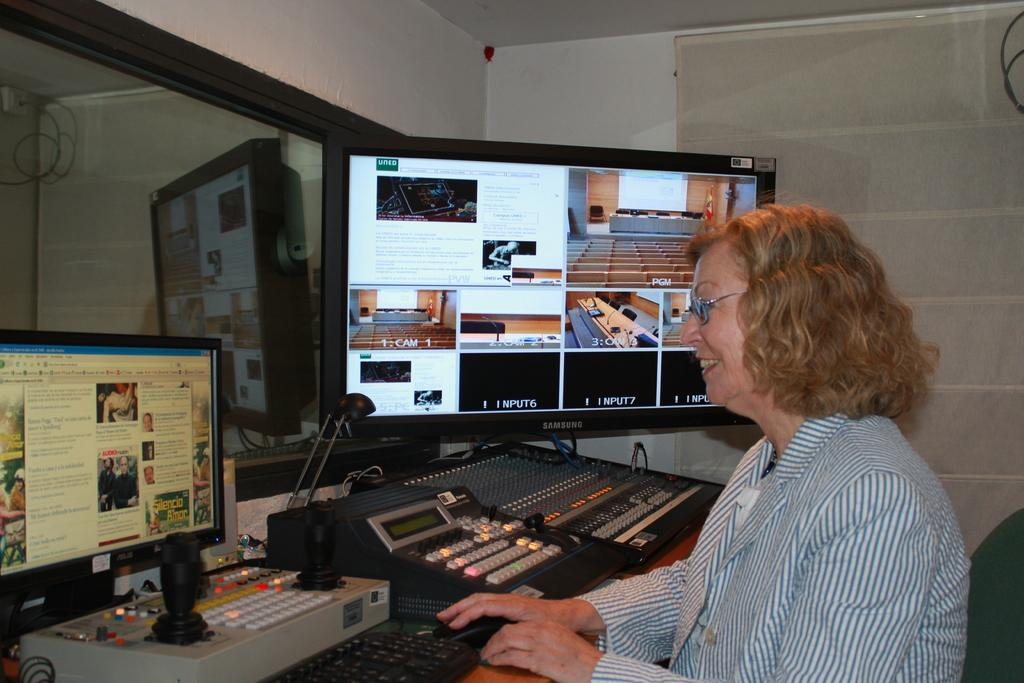<image>
Write a terse but informative summary of the picture. Woman using a computer with a large screen next to her that says Input6 on it. 